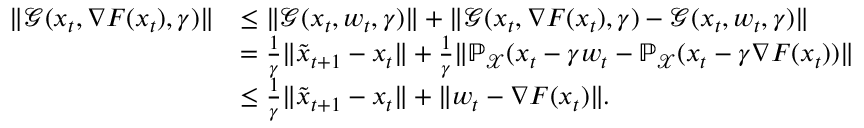Convert formula to latex. <formula><loc_0><loc_0><loc_500><loc_500>\begin{array} { r l } { \| \mathcal { G } ( x _ { t } , \nabla F ( x _ { t } ) , \gamma ) \| } & { \leq \| \mathcal { G } ( x _ { t } , w _ { t } , \gamma ) \| + \| \mathcal { G } ( x _ { t } , \nabla F ( x _ { t } ) , \gamma ) - \mathcal { G } ( x _ { t } , w _ { t } , \gamma ) \| } \\ & { = \frac { 1 } { \gamma } \| \tilde { x } _ { t + 1 } - x _ { t } \| + \frac { 1 } { \gamma } \| \mathbb { P } _ { \mathcal { X } } ( x _ { t } - \gamma w _ { t } - \mathbb { P } _ { \mathcal { X } } ( x _ { t } - \gamma \nabla F ( x _ { t } ) ) \| } \\ & { \leq \frac { 1 } { \gamma } \| \tilde { x } _ { t + 1 } - x _ { t } \| + \| w _ { t } - \nabla F ( x _ { t } ) \| . } \end{array}</formula> 